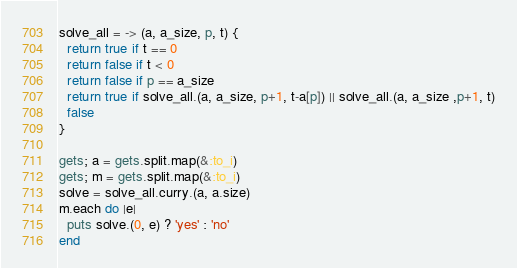Convert code to text. <code><loc_0><loc_0><loc_500><loc_500><_Ruby_>solve_all = -> (a, a_size, p, t) {
  return true if t == 0
  return false if t < 0
  return false if p == a_size
  return true if solve_all.(a, a_size, p+1, t-a[p]) || solve_all.(a, a_size ,p+1, t)
  false
}

gets; a = gets.split.map(&:to_i)
gets; m = gets.split.map(&:to_i)
solve = solve_all.curry.(a, a.size)
m.each do |e|
  puts solve.(0, e) ? 'yes' : 'no'
end</code> 